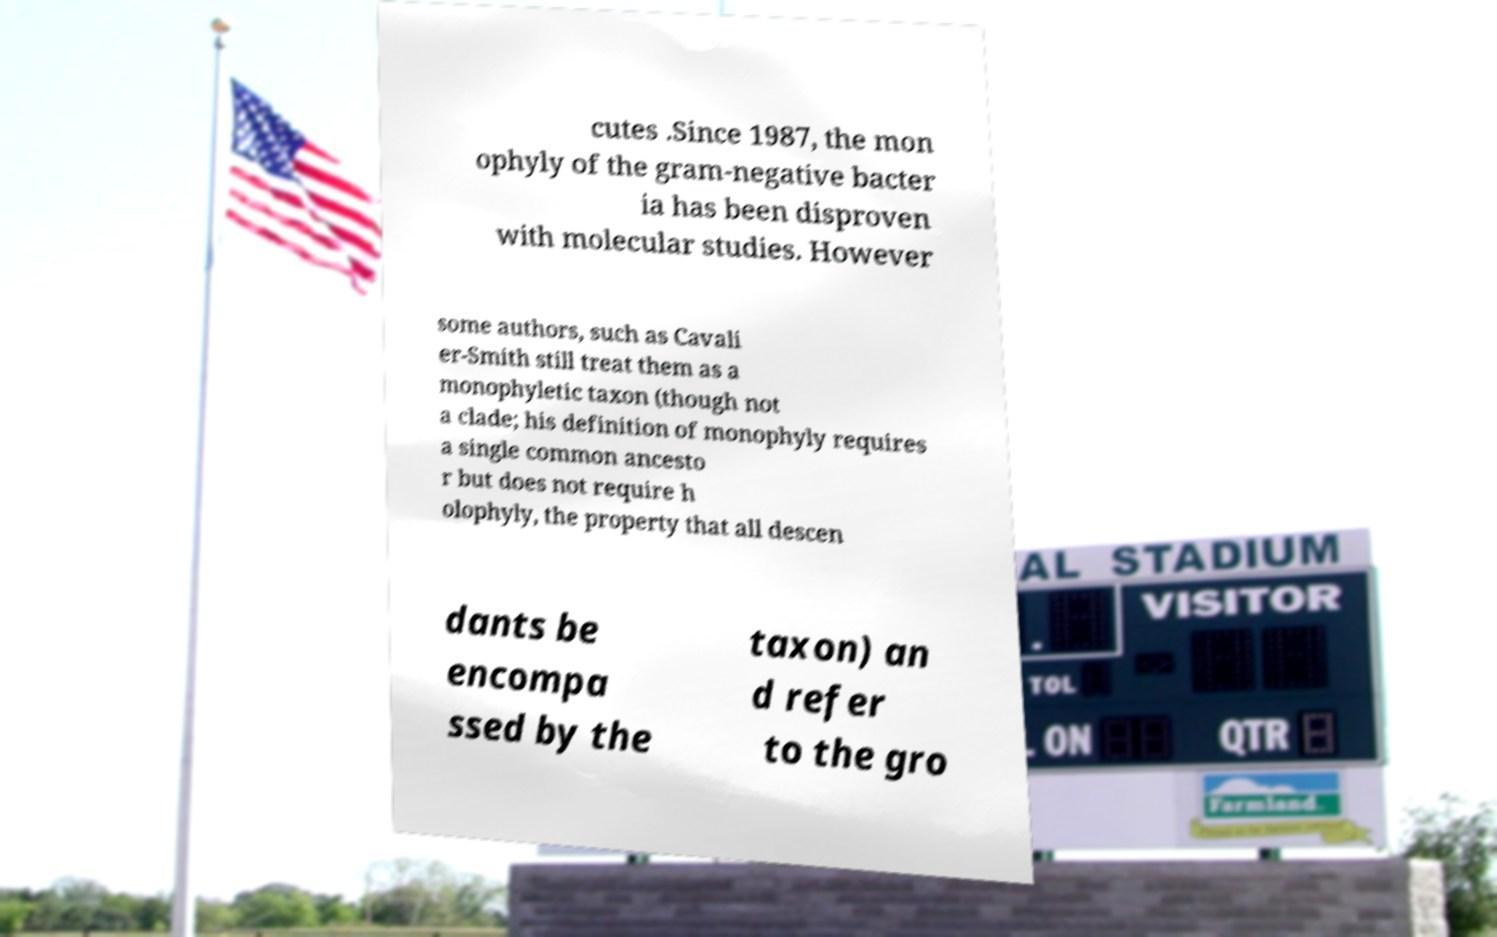Please identify and transcribe the text found in this image. cutes .Since 1987, the mon ophyly of the gram-negative bacter ia has been disproven with molecular studies. However some authors, such as Cavali er-Smith still treat them as a monophyletic taxon (though not a clade; his definition of monophyly requires a single common ancesto r but does not require h olophyly, the property that all descen dants be encompa ssed by the taxon) an d refer to the gro 